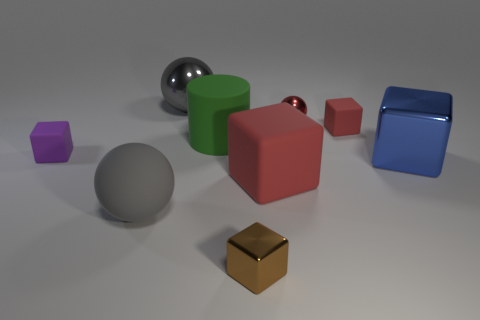What material is the large sphere that is in front of the gray thing that is behind the large matte block?
Your response must be concise. Rubber. How many other objects are there of the same material as the green cylinder?
Your answer should be very brief. 4. What material is the cylinder that is the same size as the blue block?
Your response must be concise. Rubber. Are there more large green matte cylinders that are left of the big red block than large blue blocks that are left of the tiny purple matte thing?
Your response must be concise. Yes. Are there any large gray things of the same shape as the large green matte thing?
Provide a succinct answer. No. There is a brown thing that is the same size as the purple matte object; what shape is it?
Provide a succinct answer. Cube. There is a small rubber thing that is left of the brown metal object; what is its shape?
Ensure brevity in your answer.  Cube. Is the number of large red objects on the right side of the tiny red sphere less than the number of big gray shiny objects that are to the left of the big metal ball?
Ensure brevity in your answer.  No. Is the size of the green object the same as the rubber cube that is to the left of the matte ball?
Offer a terse response. No. What number of shiny balls have the same size as the gray shiny object?
Your answer should be very brief. 0. 